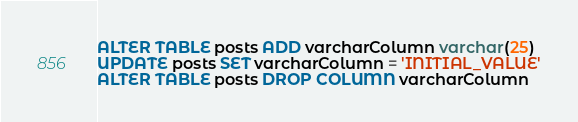Convert code to text. <code><loc_0><loc_0><loc_500><loc_500><_SQL_>ALTER TABLE posts ADD varcharColumn varchar(25)
UPDATE posts SET varcharColumn = 'INITIAL_VALUE'
ALTER TABLE posts DROP COLUMN varcharColumn</code> 